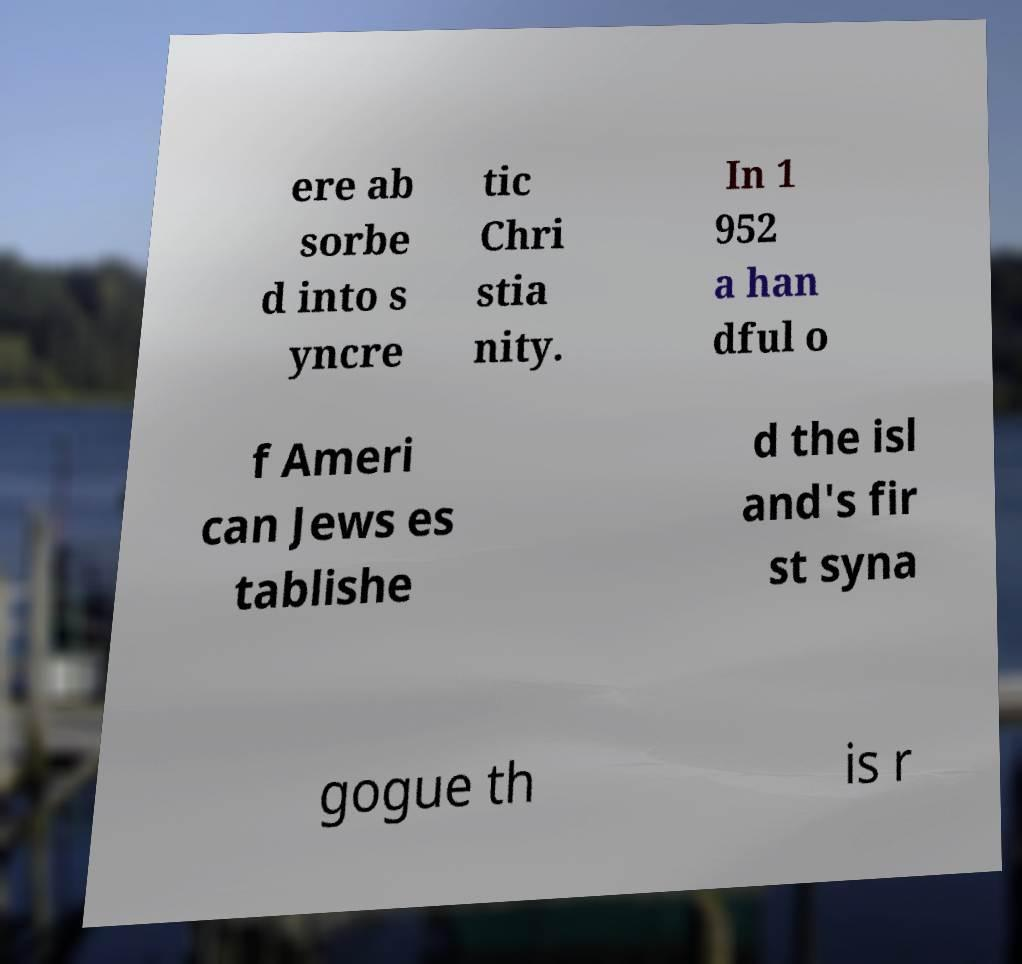Can you accurately transcribe the text from the provided image for me? ere ab sorbe d into s yncre tic Chri stia nity. In 1 952 a han dful o f Ameri can Jews es tablishe d the isl and's fir st syna gogue th is r 